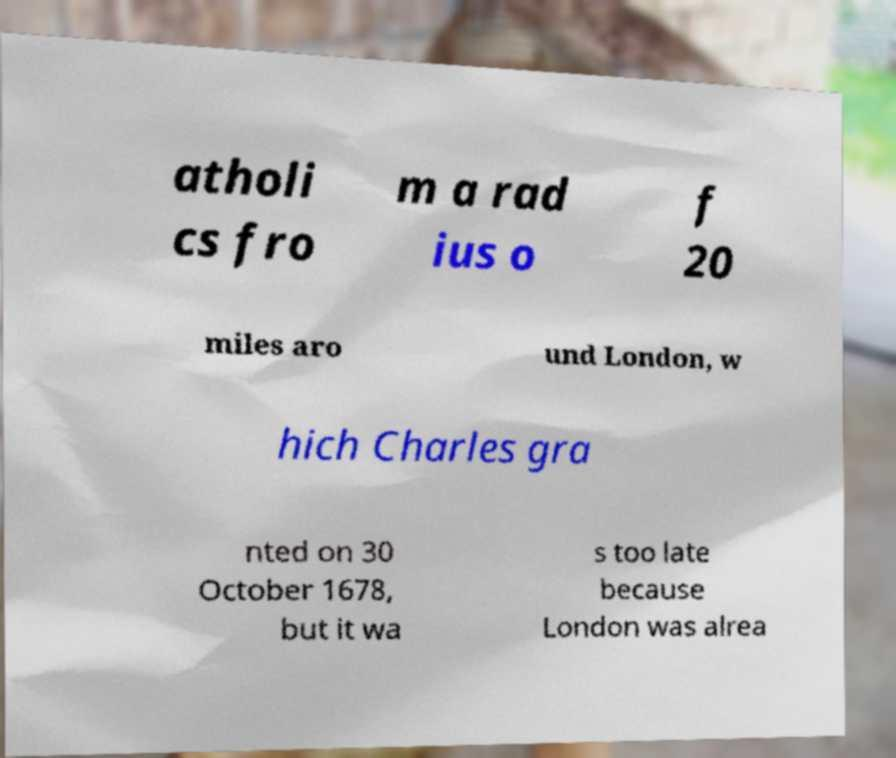Please identify and transcribe the text found in this image. atholi cs fro m a rad ius o f 20 miles aro und London, w hich Charles gra nted on 30 October 1678, but it wa s too late because London was alrea 